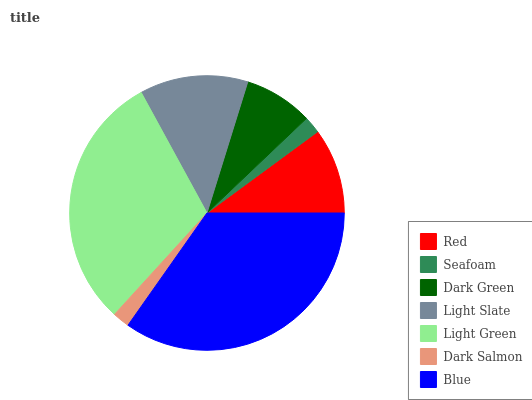Is Dark Salmon the minimum?
Answer yes or no. Yes. Is Blue the maximum?
Answer yes or no. Yes. Is Seafoam the minimum?
Answer yes or no. No. Is Seafoam the maximum?
Answer yes or no. No. Is Red greater than Seafoam?
Answer yes or no. Yes. Is Seafoam less than Red?
Answer yes or no. Yes. Is Seafoam greater than Red?
Answer yes or no. No. Is Red less than Seafoam?
Answer yes or no. No. Is Red the high median?
Answer yes or no. Yes. Is Red the low median?
Answer yes or no. Yes. Is Blue the high median?
Answer yes or no. No. Is Light Green the low median?
Answer yes or no. No. 